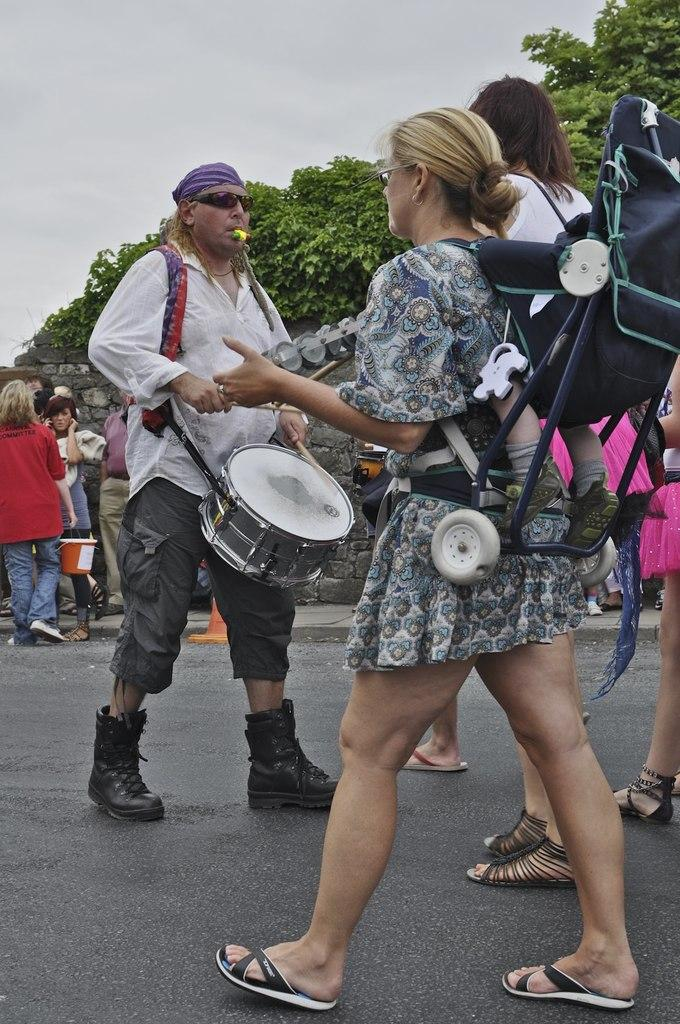Where was the image taken? The image is taken outdoors. What are the people in the image doing? The people are playing music instruments. What is the setting where the people are standing? The people are standing on a road. What can be seen in the background of the image? There are trees and the sky visible in the background. What type of jeans are the people wearing in the image? There is no information about the type of jeans the people are wearing in the image. How many times do the people twist their instruments while playing? There is no information about the people twisting their instruments while playing in the image. 